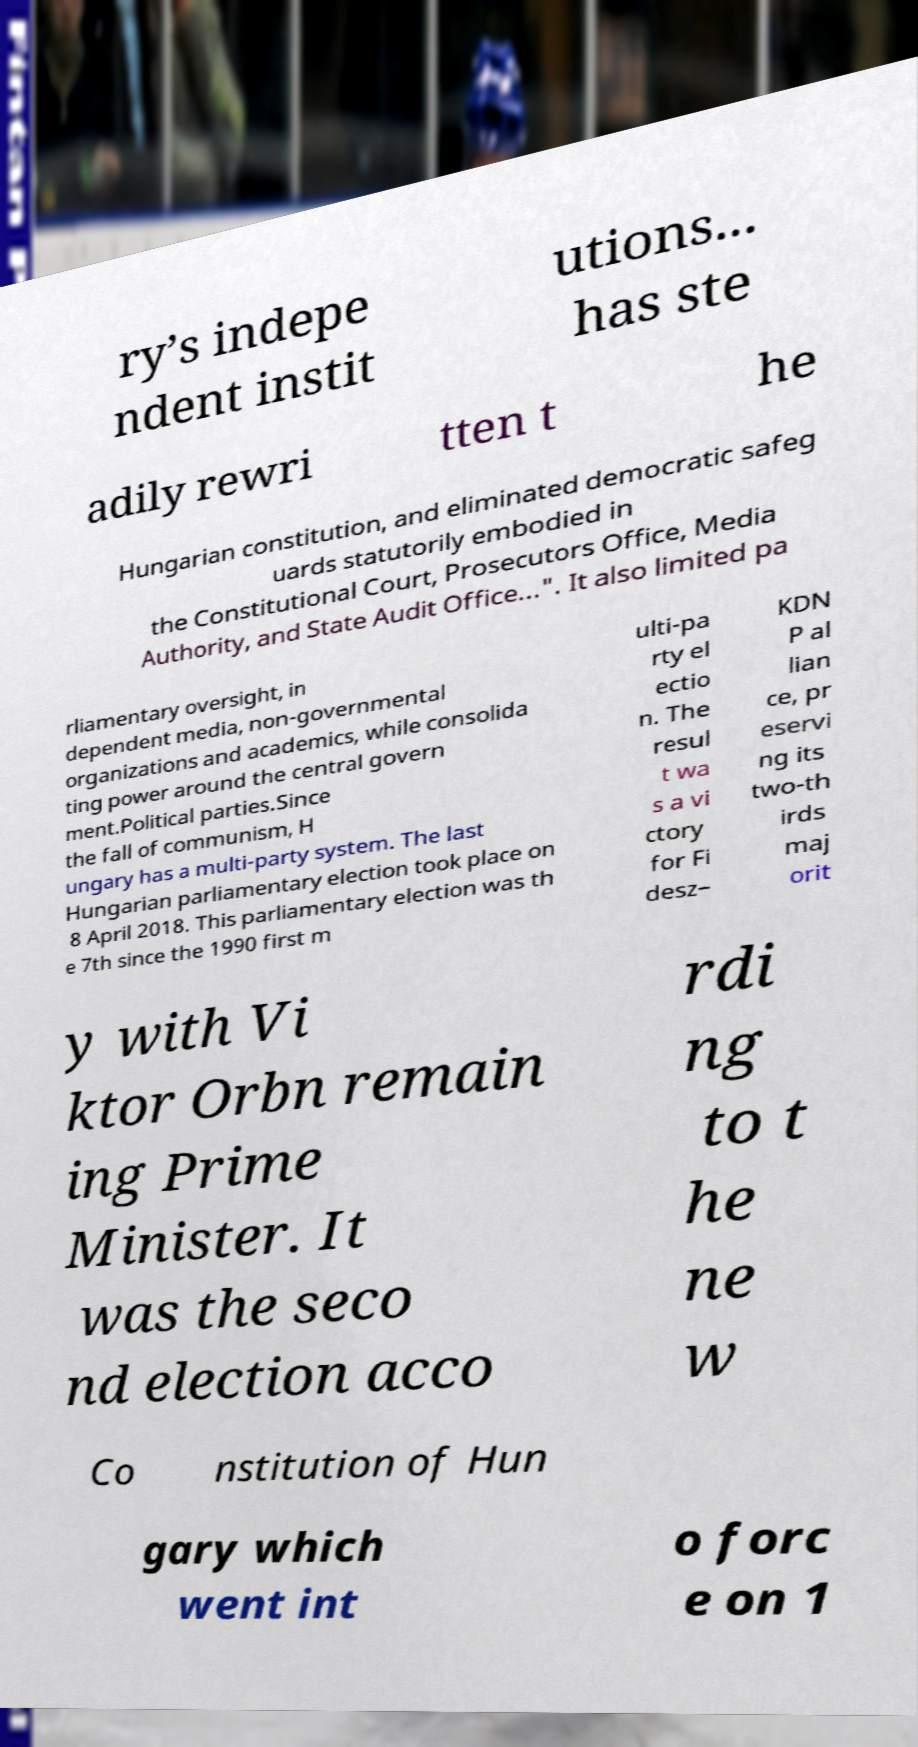For documentation purposes, I need the text within this image transcribed. Could you provide that? ry’s indepe ndent instit utions... has ste adily rewri tten t he Hungarian constitution, and eliminated democratic safeg uards statutorily embodied in the Constitutional Court, Prosecutors Office, Media Authority, and State Audit Office...". It also limited pa rliamentary oversight, in dependent media, non-governmental organizations and academics, while consolida ting power around the central govern ment.Political parties.Since the fall of communism, H ungary has a multi-party system. The last Hungarian parliamentary election took place on 8 April 2018. This parliamentary election was th e 7th since the 1990 first m ulti-pa rty el ectio n. The resul t wa s a vi ctory for Fi desz– KDN P al lian ce, pr eservi ng its two-th irds maj orit y with Vi ktor Orbn remain ing Prime Minister. It was the seco nd election acco rdi ng to t he ne w Co nstitution of Hun gary which went int o forc e on 1 